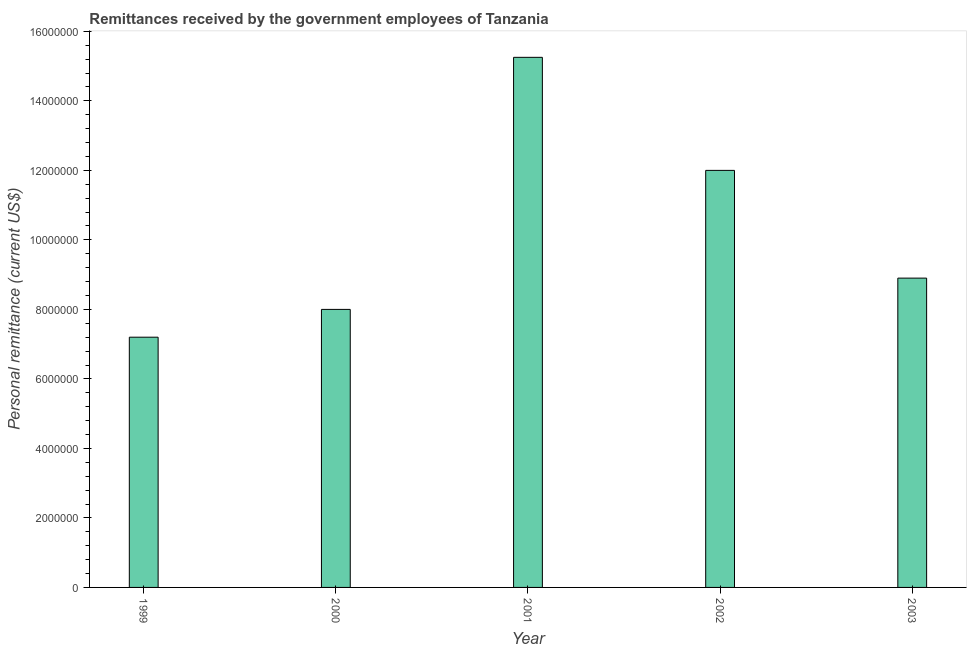Does the graph contain grids?
Your response must be concise. No. What is the title of the graph?
Provide a short and direct response. Remittances received by the government employees of Tanzania. What is the label or title of the X-axis?
Your answer should be compact. Year. What is the label or title of the Y-axis?
Provide a succinct answer. Personal remittance (current US$). Across all years, what is the maximum personal remittances?
Keep it short and to the point. 1.53e+07. Across all years, what is the minimum personal remittances?
Your answer should be very brief. 7.20e+06. In which year was the personal remittances maximum?
Keep it short and to the point. 2001. In which year was the personal remittances minimum?
Give a very brief answer. 1999. What is the sum of the personal remittances?
Offer a terse response. 5.14e+07. What is the difference between the personal remittances in 1999 and 2001?
Give a very brief answer. -8.05e+06. What is the average personal remittances per year?
Ensure brevity in your answer.  1.03e+07. What is the median personal remittances?
Your response must be concise. 8.90e+06. What is the ratio of the personal remittances in 2002 to that in 2003?
Provide a short and direct response. 1.35. Is the difference between the personal remittances in 1999 and 2000 greater than the difference between any two years?
Your response must be concise. No. What is the difference between the highest and the second highest personal remittances?
Offer a terse response. 3.25e+06. Is the sum of the personal remittances in 2000 and 2002 greater than the maximum personal remittances across all years?
Your answer should be compact. Yes. What is the difference between the highest and the lowest personal remittances?
Ensure brevity in your answer.  8.05e+06. In how many years, is the personal remittances greater than the average personal remittances taken over all years?
Offer a very short reply. 2. What is the difference between two consecutive major ticks on the Y-axis?
Your answer should be compact. 2.00e+06. What is the Personal remittance (current US$) in 1999?
Provide a succinct answer. 7.20e+06. What is the Personal remittance (current US$) in 2000?
Provide a succinct answer. 8.00e+06. What is the Personal remittance (current US$) in 2001?
Offer a terse response. 1.53e+07. What is the Personal remittance (current US$) in 2002?
Give a very brief answer. 1.20e+07. What is the Personal remittance (current US$) in 2003?
Provide a short and direct response. 8.90e+06. What is the difference between the Personal remittance (current US$) in 1999 and 2000?
Offer a terse response. -8.00e+05. What is the difference between the Personal remittance (current US$) in 1999 and 2001?
Ensure brevity in your answer.  -8.05e+06. What is the difference between the Personal remittance (current US$) in 1999 and 2002?
Offer a terse response. -4.80e+06. What is the difference between the Personal remittance (current US$) in 1999 and 2003?
Offer a terse response. -1.70e+06. What is the difference between the Personal remittance (current US$) in 2000 and 2001?
Offer a very short reply. -7.25e+06. What is the difference between the Personal remittance (current US$) in 2000 and 2002?
Make the answer very short. -4.00e+06. What is the difference between the Personal remittance (current US$) in 2000 and 2003?
Ensure brevity in your answer.  -9.00e+05. What is the difference between the Personal remittance (current US$) in 2001 and 2002?
Offer a very short reply. 3.25e+06. What is the difference between the Personal remittance (current US$) in 2001 and 2003?
Provide a succinct answer. 6.35e+06. What is the difference between the Personal remittance (current US$) in 2002 and 2003?
Offer a terse response. 3.10e+06. What is the ratio of the Personal remittance (current US$) in 1999 to that in 2000?
Provide a short and direct response. 0.9. What is the ratio of the Personal remittance (current US$) in 1999 to that in 2001?
Your answer should be very brief. 0.47. What is the ratio of the Personal remittance (current US$) in 1999 to that in 2002?
Offer a very short reply. 0.6. What is the ratio of the Personal remittance (current US$) in 1999 to that in 2003?
Keep it short and to the point. 0.81. What is the ratio of the Personal remittance (current US$) in 2000 to that in 2001?
Make the answer very short. 0.52. What is the ratio of the Personal remittance (current US$) in 2000 to that in 2002?
Ensure brevity in your answer.  0.67. What is the ratio of the Personal remittance (current US$) in 2000 to that in 2003?
Your answer should be very brief. 0.9. What is the ratio of the Personal remittance (current US$) in 2001 to that in 2002?
Your answer should be compact. 1.27. What is the ratio of the Personal remittance (current US$) in 2001 to that in 2003?
Make the answer very short. 1.71. What is the ratio of the Personal remittance (current US$) in 2002 to that in 2003?
Offer a terse response. 1.35. 